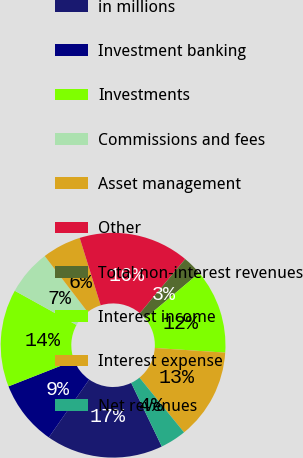Convert chart. <chart><loc_0><loc_0><loc_500><loc_500><pie_chart><fcel>in millions<fcel>Investment banking<fcel>Investments<fcel>Commissions and fees<fcel>Asset management<fcel>Other<fcel>Total non-interest revenues<fcel>Interest income<fcel>Interest expense<fcel>Net revenues<nl><fcel>16.82%<fcel>9.35%<fcel>14.02%<fcel>6.54%<fcel>5.61%<fcel>15.89%<fcel>2.81%<fcel>12.15%<fcel>13.08%<fcel>3.74%<nl></chart> 